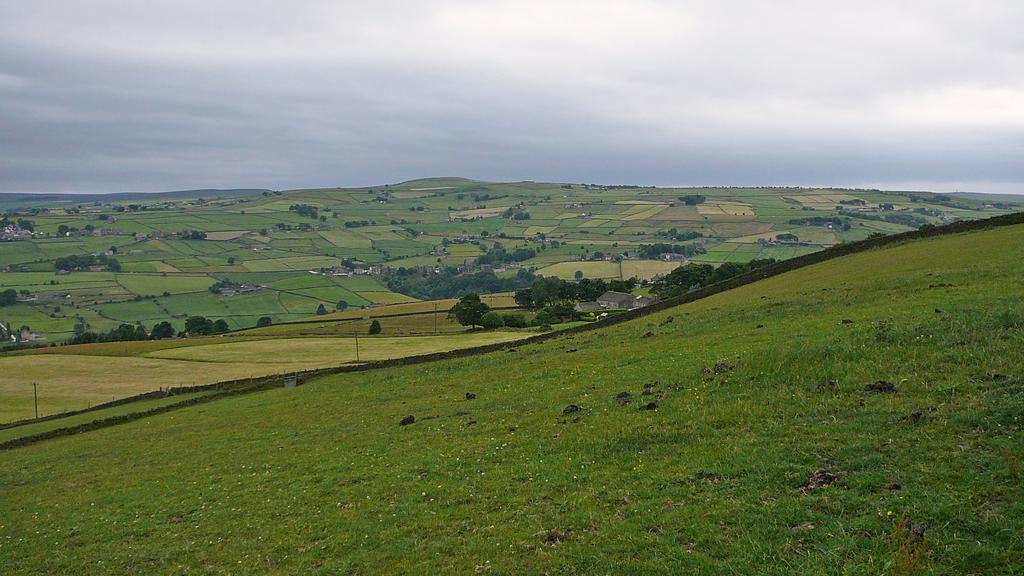Can you describe this image briefly? In this image there are fields and we can see trees. In the background there are hills and sky. 